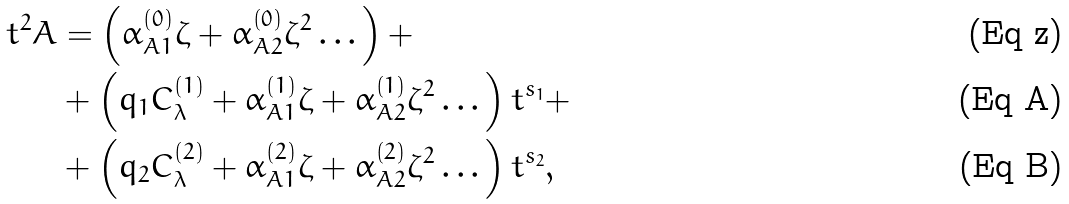<formula> <loc_0><loc_0><loc_500><loc_500>t ^ { 2 } A & = \left ( \alpha _ { A 1 } ^ { \left ( 0 \right ) } \zeta + \alpha _ { A 2 } ^ { \left ( 0 \right ) } \zeta ^ { 2 } \dots \right ) + \\ & + \left ( q _ { 1 } C _ { \lambda } ^ { \left ( 1 \right ) } + \alpha _ { A 1 } ^ { \left ( 1 \right ) } \zeta + \alpha _ { A 2 } ^ { \left ( 1 \right ) } \zeta ^ { 2 } \dots \right ) t ^ { s _ { 1 } } + \\ & + \left ( q _ { 2 } C _ { \lambda } ^ { \left ( 2 \right ) } + \alpha _ { A 1 } ^ { \left ( 2 \right ) } \zeta + \alpha _ { A 2 } ^ { \left ( 2 \right ) } \zeta ^ { 2 } \dots \right ) t ^ { s _ { 2 } } ,</formula> 